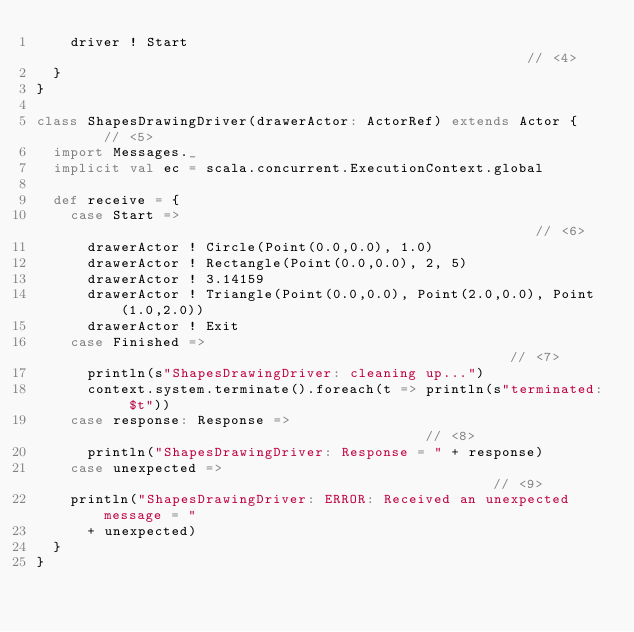<code> <loc_0><loc_0><loc_500><loc_500><_Scala_>    driver ! Start                                                   // <4>
  }
}

class ShapesDrawingDriver(drawerActor: ActorRef) extends Actor {     // <5>
  import Messages._
  implicit val ec = scala.concurrent.ExecutionContext.global

  def receive = {
    case Start =>                                                    // <6>
      drawerActor ! Circle(Point(0.0,0.0), 1.0)
      drawerActor ! Rectangle(Point(0.0,0.0), 2, 5)
      drawerActor ! 3.14159
      drawerActor ! Triangle(Point(0.0,0.0), Point(2.0,0.0), Point(1.0,2.0))
      drawerActor ! Exit
    case Finished =>                                                 // <7>
      println(s"ShapesDrawingDriver: cleaning up...")
      context.system.terminate().foreach(t => println(s"terminated: $t"))
    case response: Response =>                                       // <8>
      println("ShapesDrawingDriver: Response = " + response)
    case unexpected =>                                               // <9>
    println("ShapesDrawingDriver: ERROR: Received an unexpected message = "
      + unexpected)
  }
}
</code> 